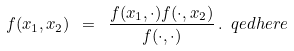Convert formula to latex. <formula><loc_0><loc_0><loc_500><loc_500>f ( x _ { 1 } , x _ { 2 } ) \ = \ \frac { f ( x _ { 1 } , \cdot ) f ( \cdot , x _ { 2 } ) } { f ( \cdot , \cdot ) } \, . \ q e d h e r e</formula> 